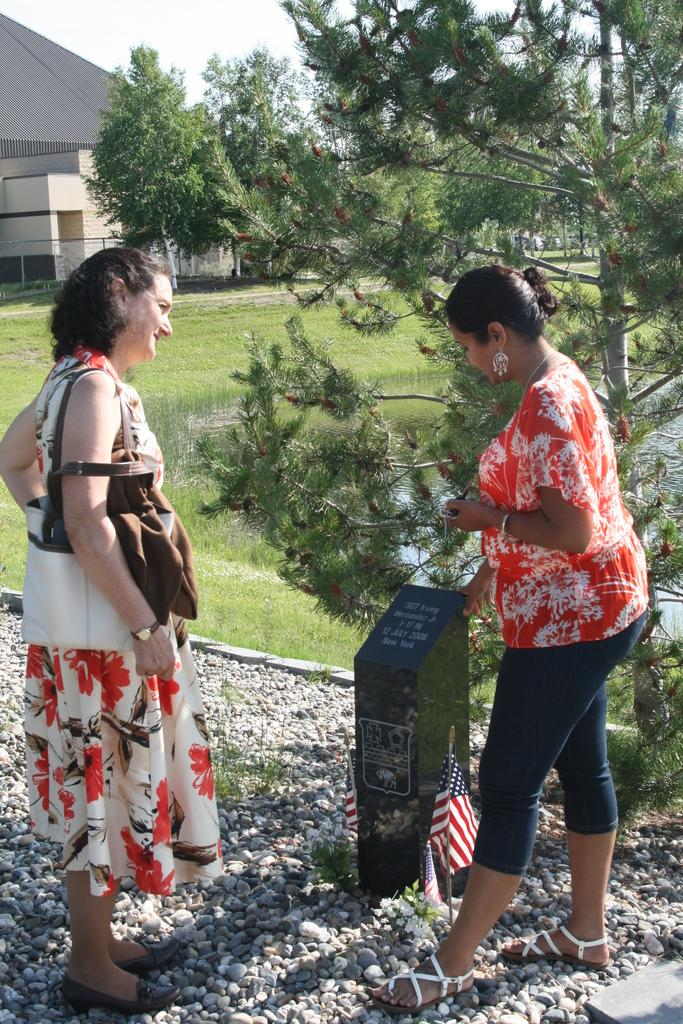How many girls are in the image? There are two girls in the image. What are the girls standing on? The girls are standing on rocks. What is on the ground near the girls? There is a flag on the ground. What can be seen in the background of the image? There are trees and buildings in the background of the image. What type of jelly can be seen on the girls' hands in the image? There is no jelly present on the girls' hands or anywhere else in the image. 